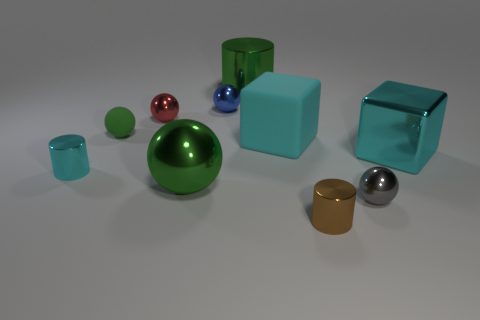How many green balls must be subtracted to get 1 green balls? 1 Subtract all tiny blue balls. How many balls are left? 4 Subtract 2 cylinders. How many cylinders are left? 1 Subtract all red spheres. How many spheres are left? 4 Subtract all blocks. How many objects are left? 8 Subtract all small cyan metallic things. Subtract all balls. How many objects are left? 4 Add 2 metal balls. How many metal balls are left? 6 Add 6 large metallic objects. How many large metallic objects exist? 9 Subtract 0 blue cylinders. How many objects are left? 10 Subtract all blue cylinders. Subtract all red blocks. How many cylinders are left? 3 